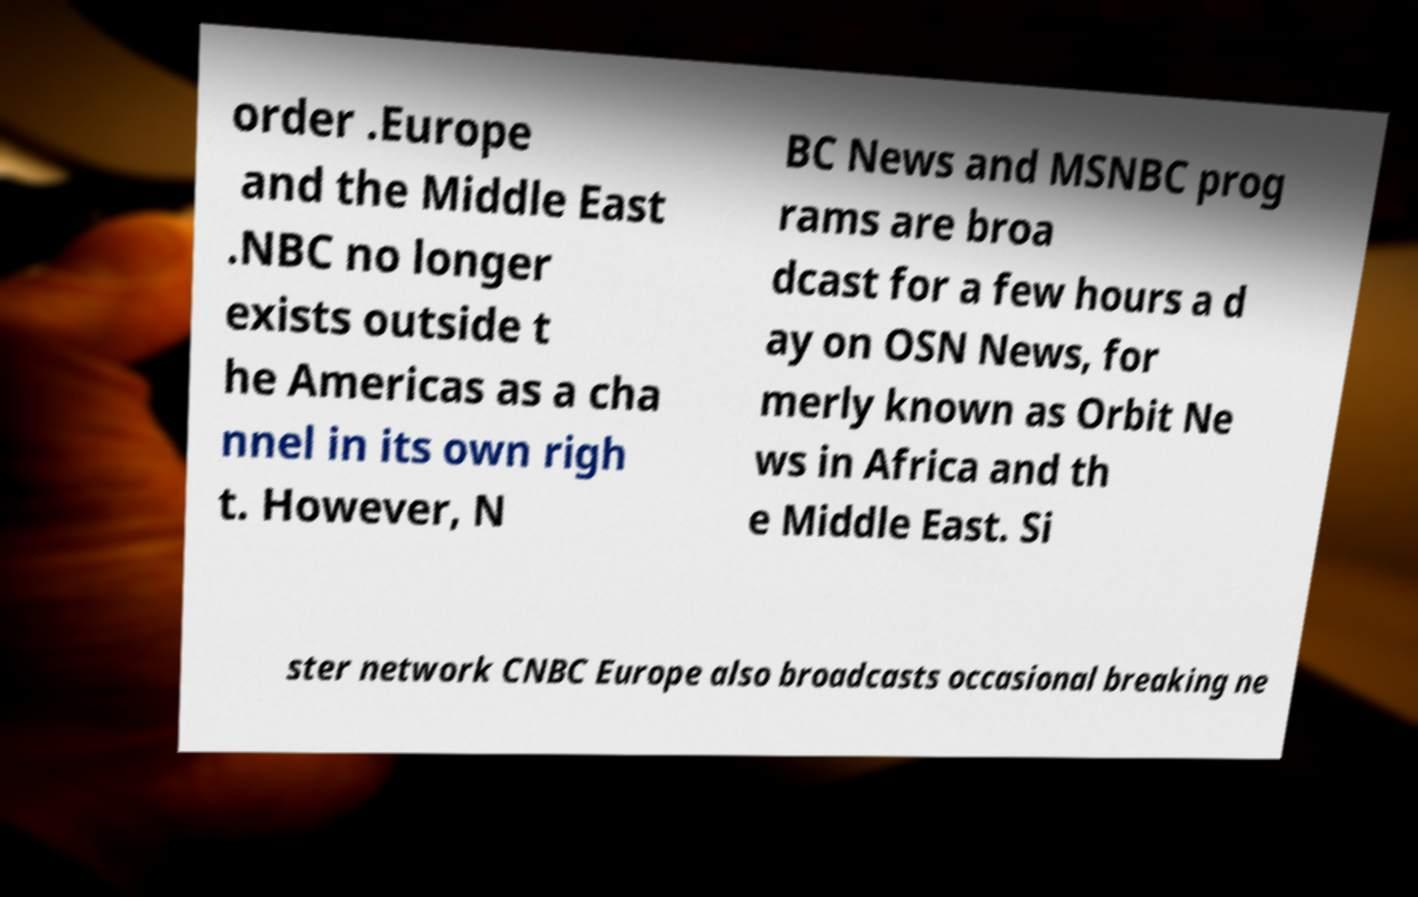For documentation purposes, I need the text within this image transcribed. Could you provide that? order .Europe and the Middle East .NBC no longer exists outside t he Americas as a cha nnel in its own righ t. However, N BC News and MSNBC prog rams are broa dcast for a few hours a d ay on OSN News, for merly known as Orbit Ne ws in Africa and th e Middle East. Si ster network CNBC Europe also broadcasts occasional breaking ne 